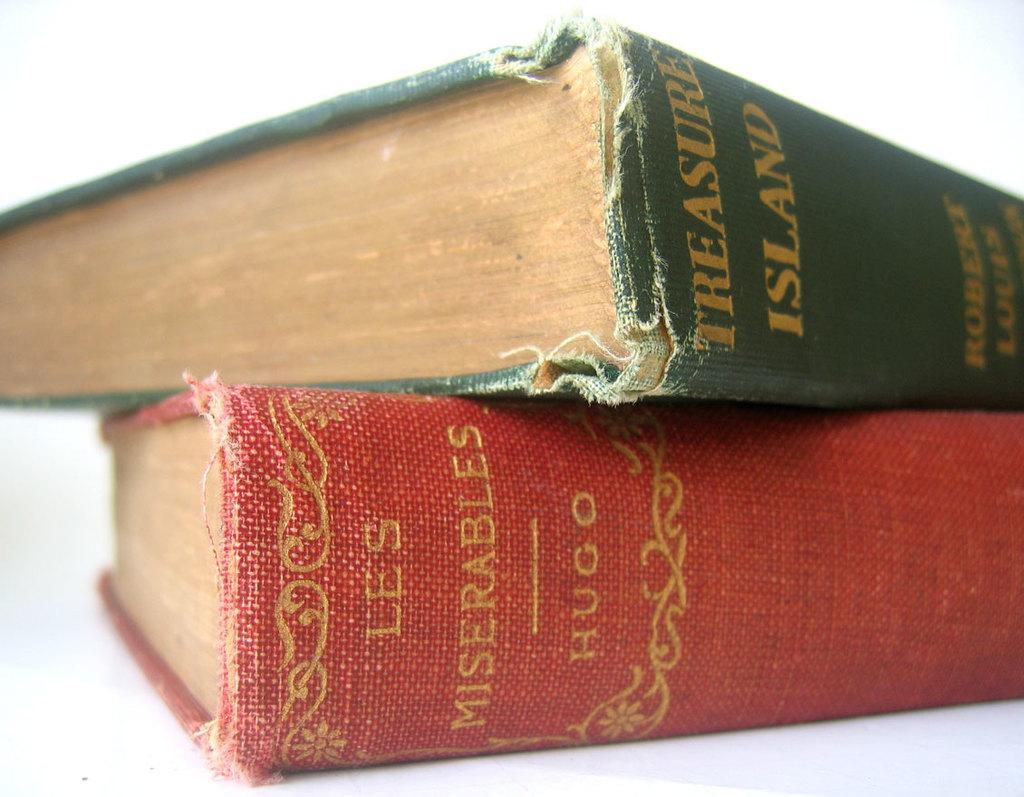<image>
Offer a succinct explanation of the picture presented. The books treasure island and Les Miserables are on top of each other. 